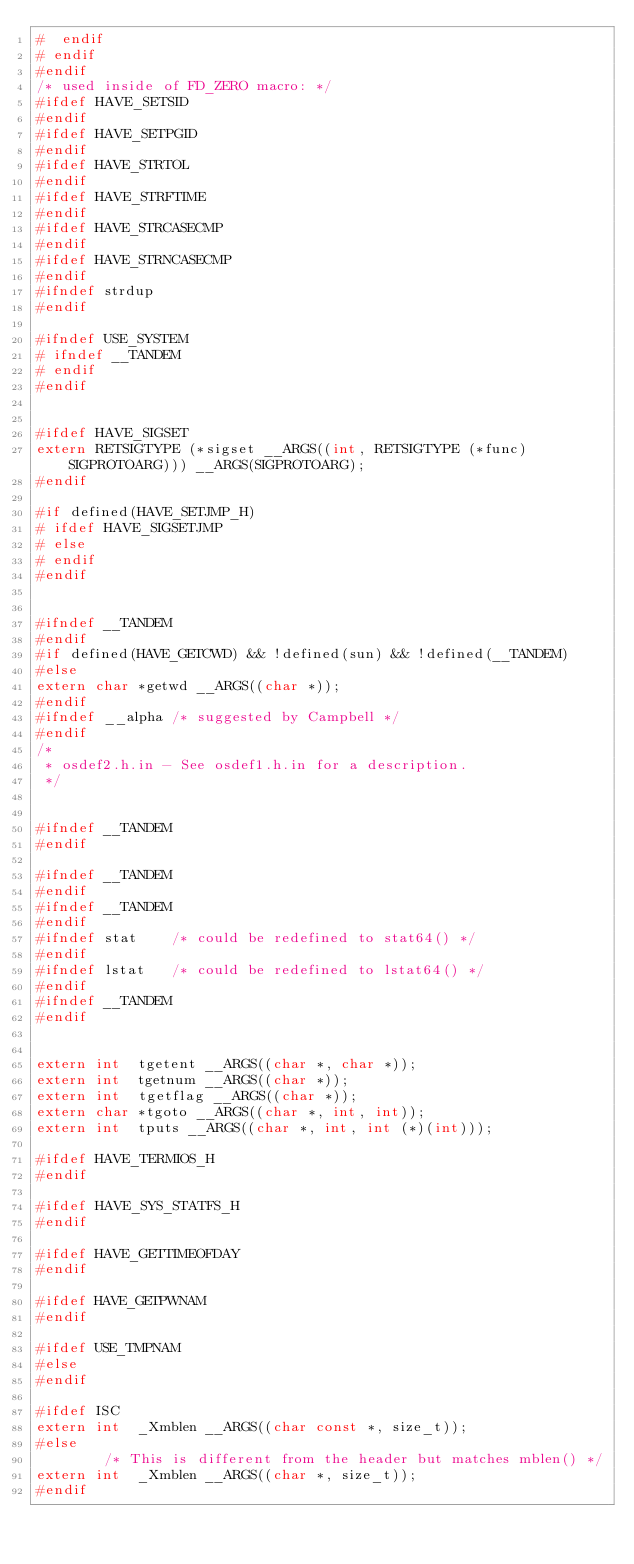<code> <loc_0><loc_0><loc_500><loc_500><_C_>#  endif
# endif
#endif
/* used inside of FD_ZERO macro: */
#ifdef HAVE_SETSID
#endif
#ifdef HAVE_SETPGID
#endif
#ifdef HAVE_STRTOL
#endif
#ifdef HAVE_STRFTIME
#endif
#ifdef HAVE_STRCASECMP
#endif
#ifdef HAVE_STRNCASECMP
#endif
#ifndef strdup
#endif

#ifndef USE_SYSTEM
# ifndef __TANDEM
# endif
#endif


#ifdef HAVE_SIGSET
extern RETSIGTYPE (*sigset __ARGS((int, RETSIGTYPE (*func) SIGPROTOARG))) __ARGS(SIGPROTOARG);
#endif

#if defined(HAVE_SETJMP_H)
# ifdef HAVE_SIGSETJMP
# else
# endif
#endif


#ifndef __TANDEM
#endif
#if defined(HAVE_GETCWD) && !defined(sun) && !defined(__TANDEM)
#else
extern char	*getwd __ARGS((char *));
#endif
#ifndef __alpha	/* suggested by Campbell */
#endif
/*
 * osdef2.h.in - See osdef1.h.in for a description.
 */


#ifndef __TANDEM
#endif

#ifndef __TANDEM
#endif
#ifndef __TANDEM
#endif
#ifndef stat	/* could be redefined to stat64() */
#endif
#ifndef lstat	/* could be redefined to lstat64() */
#endif
#ifndef __TANDEM
#endif


extern int	tgetent __ARGS((char *, char *));
extern int	tgetnum __ARGS((char *));
extern int	tgetflag __ARGS((char *));
extern char	*tgoto __ARGS((char *, int, int));
extern int	tputs __ARGS((char *, int, int (*)(int)));

#ifdef HAVE_TERMIOS_H
#endif

#ifdef HAVE_SYS_STATFS_H
#endif

#ifdef HAVE_GETTIMEOFDAY
#endif

#ifdef HAVE_GETPWNAM
#endif

#ifdef USE_TMPNAM
#else
#endif

#ifdef ISC
extern int	_Xmblen __ARGS((char const *, size_t));
#else
		/* This is different from the header but matches mblen() */
extern int	_Xmblen __ARGS((char *, size_t));
#endif
</code> 